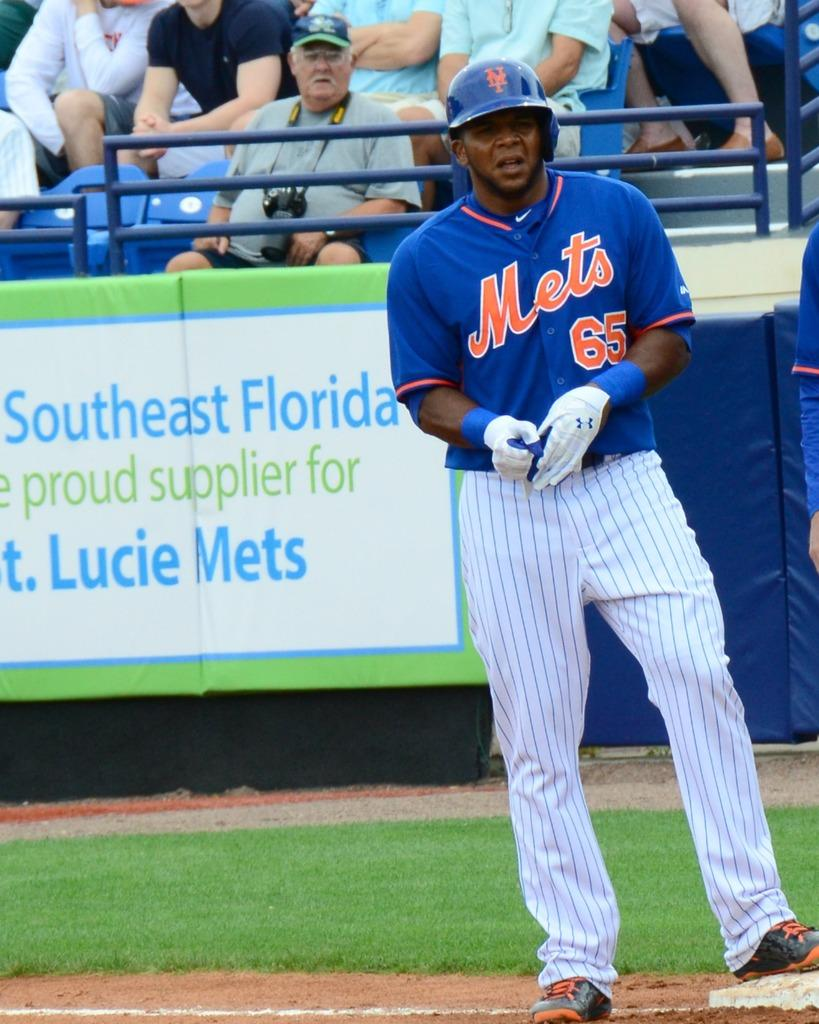<image>
Provide a brief description of the given image. A baseball player in a blue Mets uniform. 